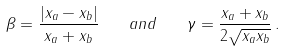Convert formula to latex. <formula><loc_0><loc_0><loc_500><loc_500>\beta = \frac { | x _ { a } - x _ { b } | } { x _ { a } + x _ { b } } \quad a n d \quad \gamma = \frac { x _ { a } + x _ { b } } { 2 \sqrt { x _ { a } x _ { b } } } \, .</formula> 